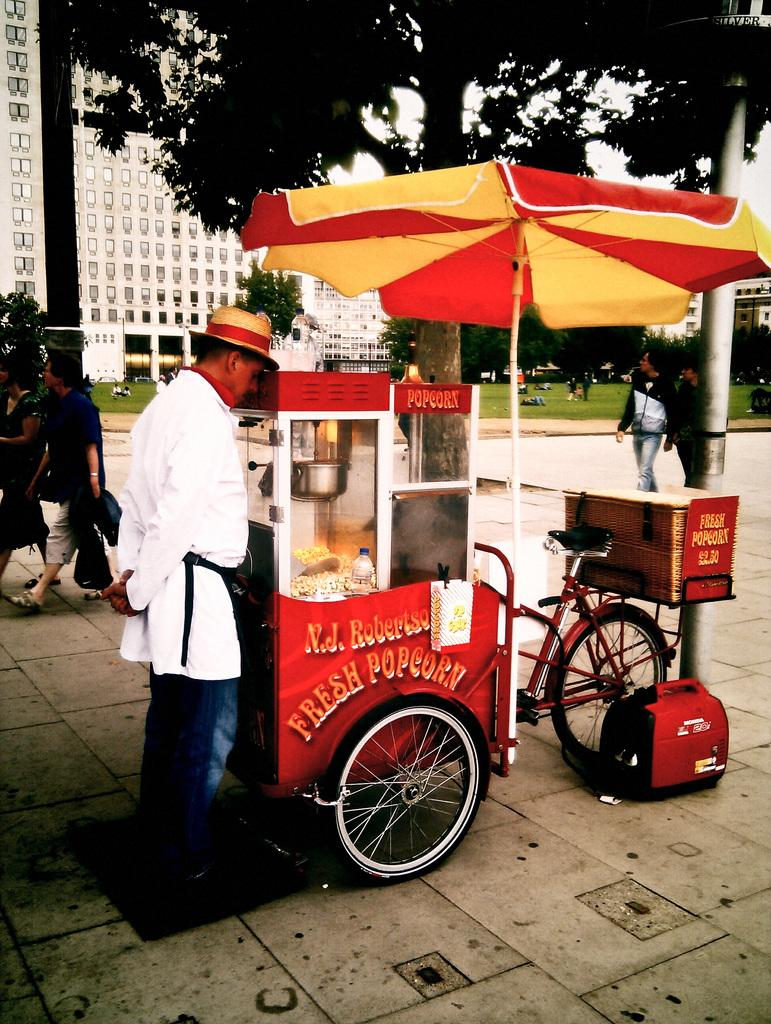What is the main subject of the image? The main subject of the image is a popcorn bike. Can you describe the man standing on the left side of the image? There is a man standing on the left side of the image. What are the people in the image doing? The people in the image are walking. What can be seen in the background of the image? There are buildings, trees, and the sky visible in the background of the image. How many tickets does the sponge have in the image? There is no sponge or tickets present in the image. What type of trouble is the man on the left side of the image facing? There is no indication of trouble in the image; the man is simply standing on the left side. 